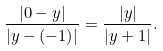<formula> <loc_0><loc_0><loc_500><loc_500>\frac { | 0 - y | } { | y - ( - 1 ) | } = \frac { | y | } { | y + 1 | } .</formula> 